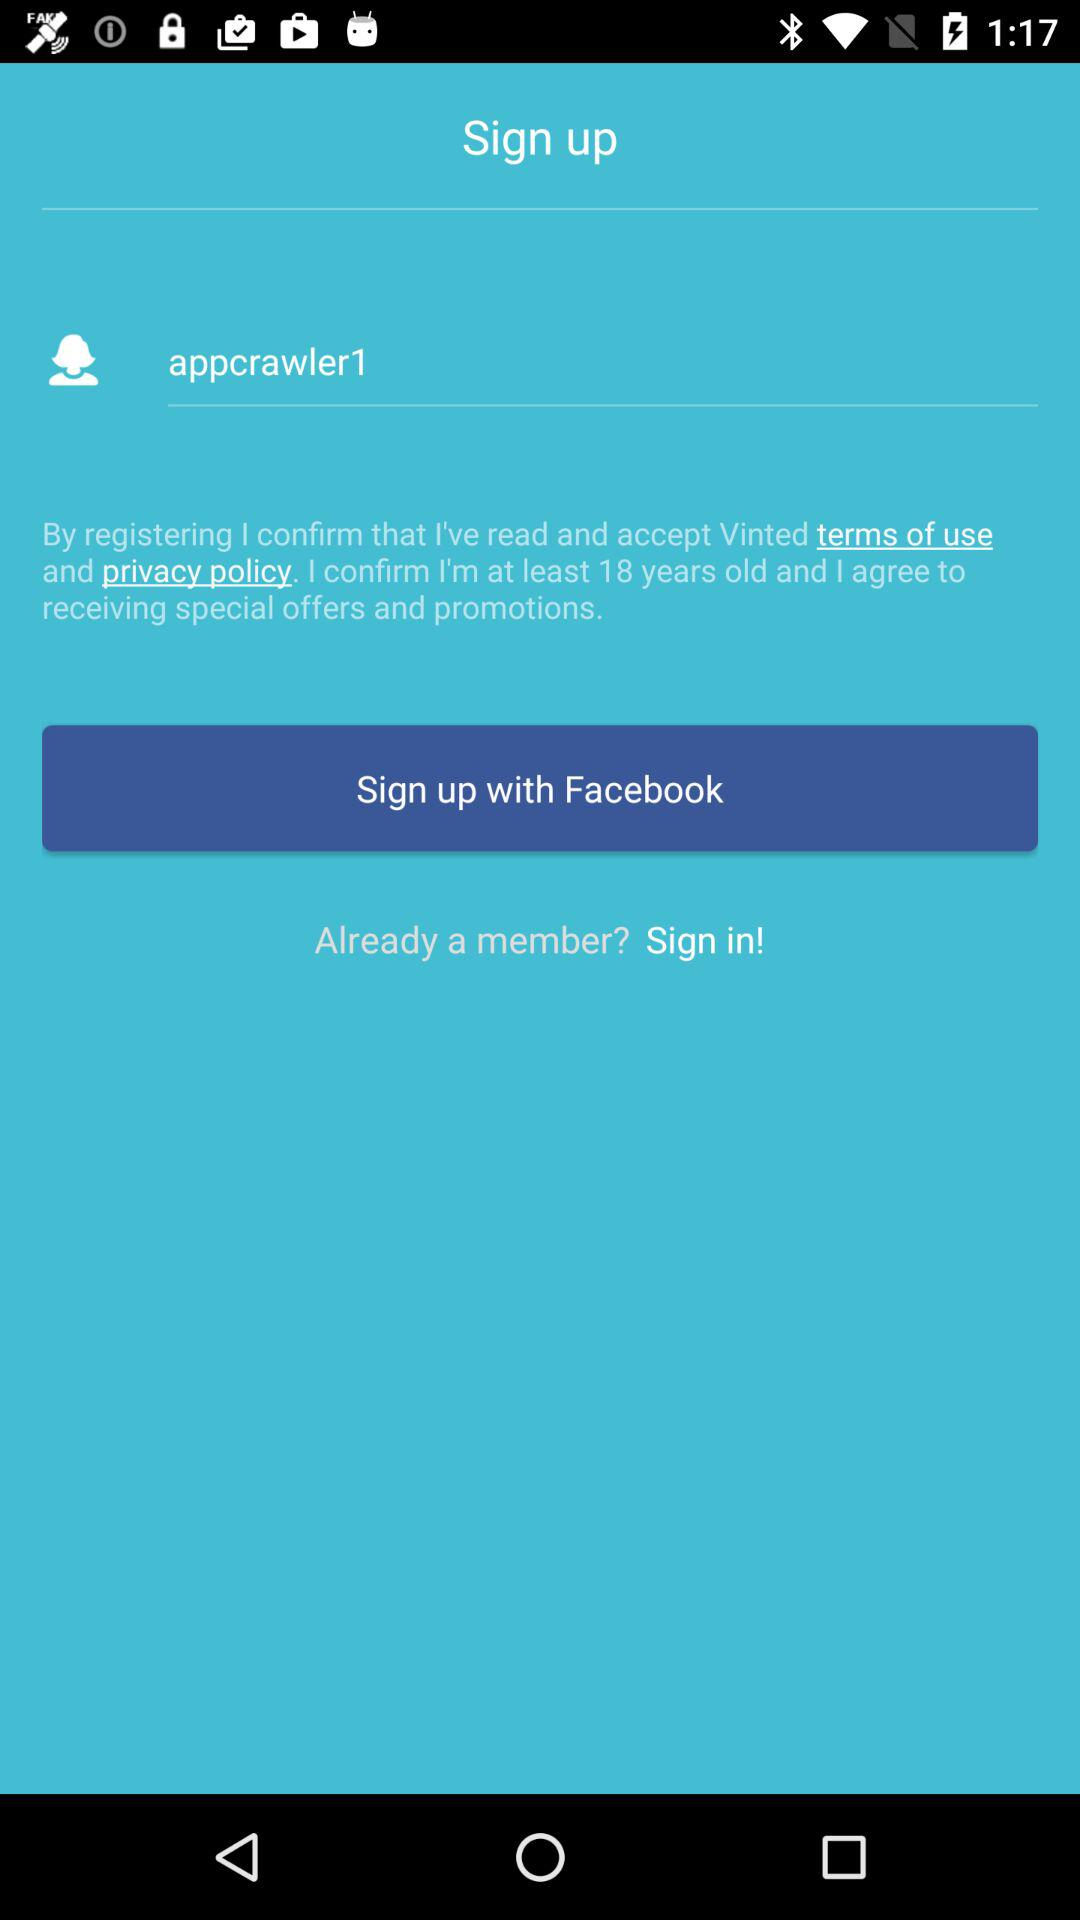How many text fields are required to create an account?
Answer the question using a single word or phrase. 1 